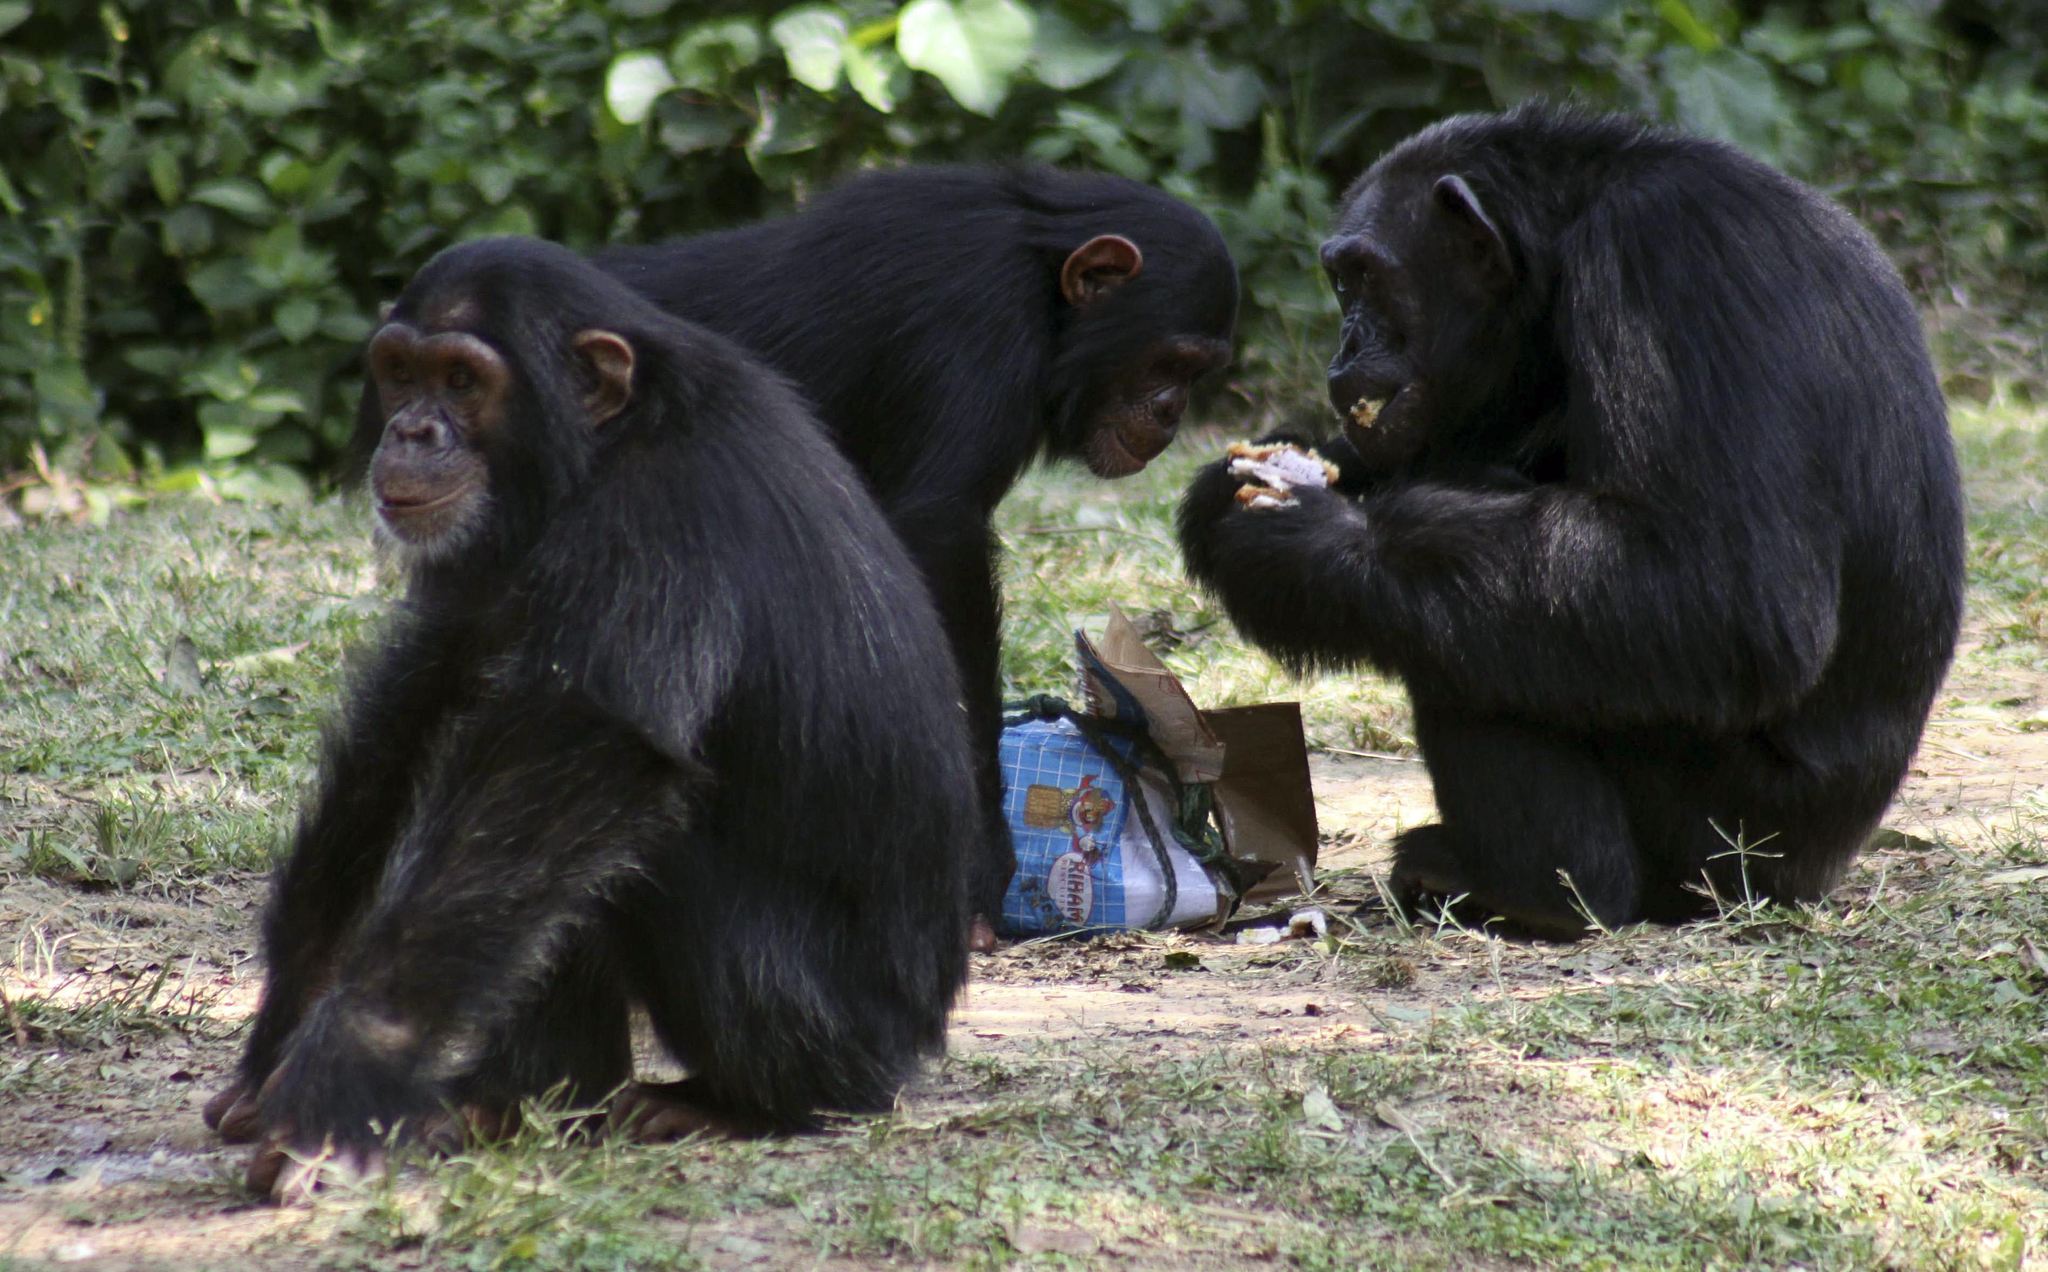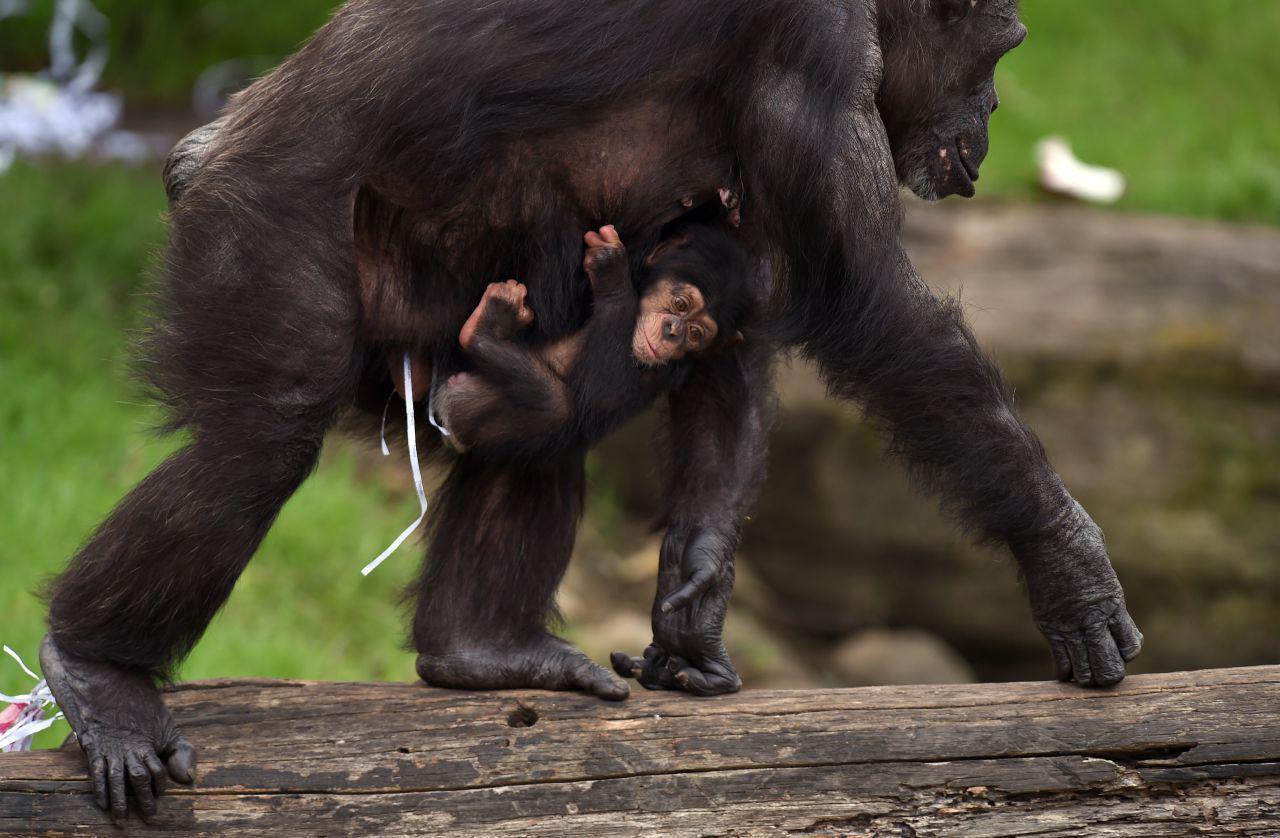The first image is the image on the left, the second image is the image on the right. Examine the images to the left and right. Is the description "An image contains exactly two chimps, and both chimps are sitting on the ground." accurate? Answer yes or no. No. The first image is the image on the left, the second image is the image on the right. For the images displayed, is the sentence "A baboon is carrying a baby baboon in the image on the right." factually correct? Answer yes or no. Yes. 